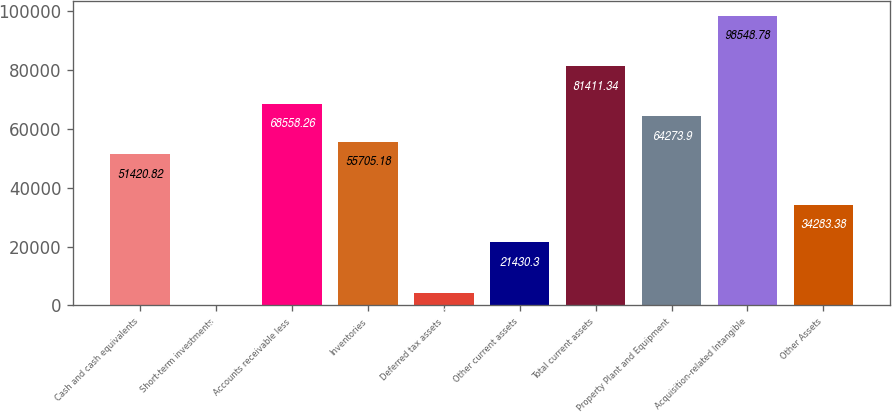<chart> <loc_0><loc_0><loc_500><loc_500><bar_chart><fcel>Cash and cash equivalents<fcel>Short-term investments<fcel>Accounts receivable less<fcel>Inventories<fcel>Deferred tax assets<fcel>Other current assets<fcel>Total current assets<fcel>Property Plant and Equipment<fcel>Acquisition-related Intangible<fcel>Other Assets<nl><fcel>51420.8<fcel>8.5<fcel>68558.3<fcel>55705.2<fcel>4292.86<fcel>21430.3<fcel>81411.3<fcel>64273.9<fcel>98548.8<fcel>34283.4<nl></chart> 